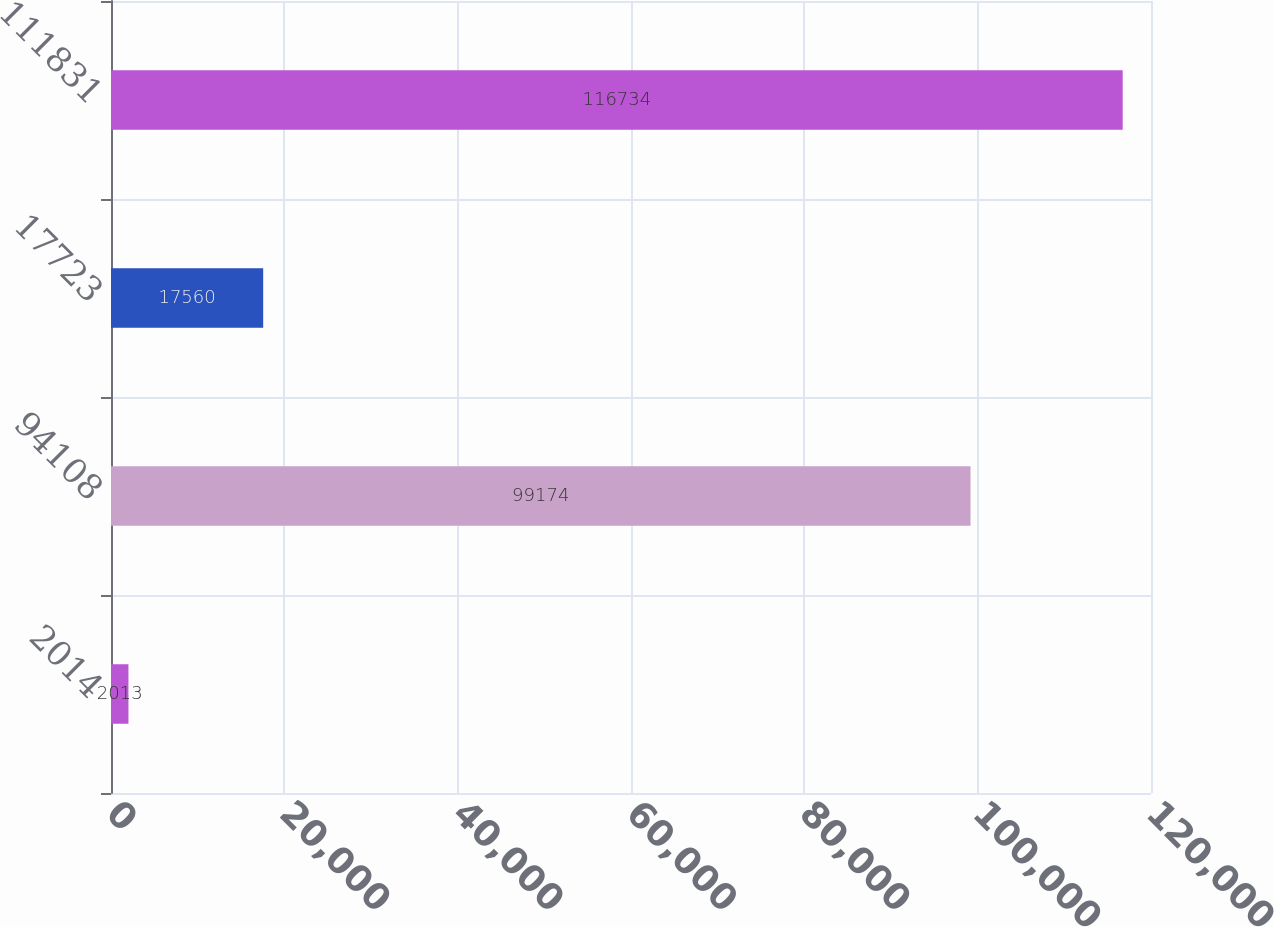Convert chart. <chart><loc_0><loc_0><loc_500><loc_500><bar_chart><fcel>2014<fcel>94108<fcel>17723<fcel>111831<nl><fcel>2013<fcel>99174<fcel>17560<fcel>116734<nl></chart> 